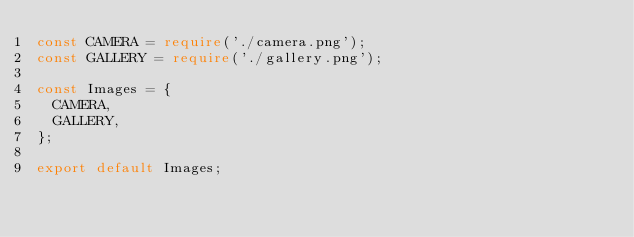<code> <loc_0><loc_0><loc_500><loc_500><_TypeScript_>const CAMERA = require('./camera.png');
const GALLERY = require('./gallery.png');

const Images = {
  CAMERA,
  GALLERY,
};

export default Images;
</code> 